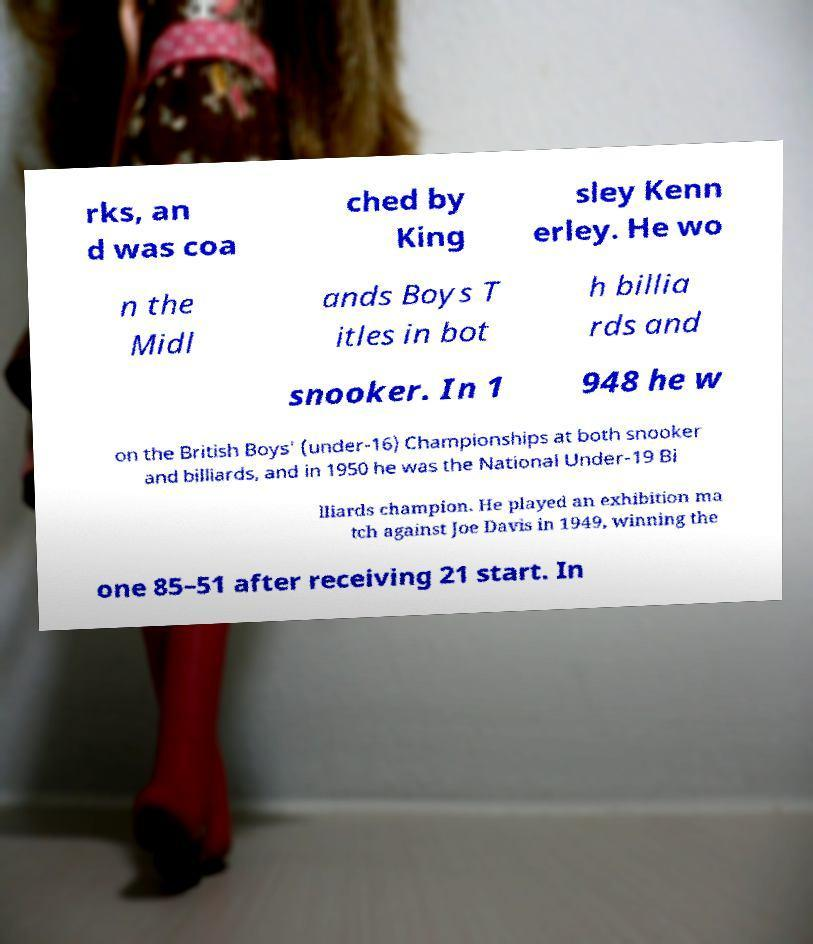Can you read and provide the text displayed in the image?This photo seems to have some interesting text. Can you extract and type it out for me? rks, an d was coa ched by King sley Kenn erley. He wo n the Midl ands Boys T itles in bot h billia rds and snooker. In 1 948 he w on the British Boys' (under-16) Championships at both snooker and billiards, and in 1950 he was the National Under-19 Bi lliards champion. He played an exhibition ma tch against Joe Davis in 1949, winning the one 85–51 after receiving 21 start. In 